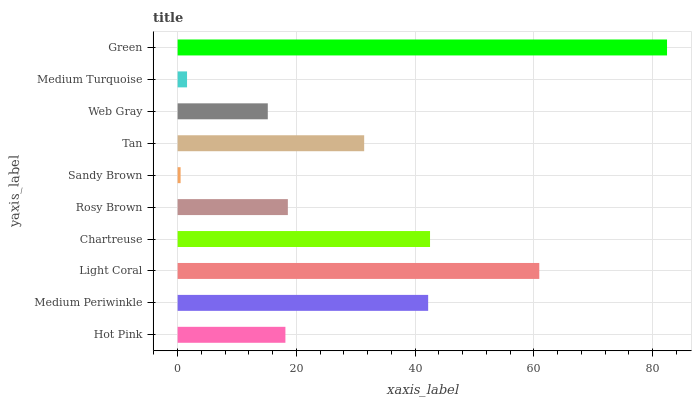Is Sandy Brown the minimum?
Answer yes or no. Yes. Is Green the maximum?
Answer yes or no. Yes. Is Medium Periwinkle the minimum?
Answer yes or no. No. Is Medium Periwinkle the maximum?
Answer yes or no. No. Is Medium Periwinkle greater than Hot Pink?
Answer yes or no. Yes. Is Hot Pink less than Medium Periwinkle?
Answer yes or no. Yes. Is Hot Pink greater than Medium Periwinkle?
Answer yes or no. No. Is Medium Periwinkle less than Hot Pink?
Answer yes or no. No. Is Tan the high median?
Answer yes or no. Yes. Is Rosy Brown the low median?
Answer yes or no. Yes. Is Hot Pink the high median?
Answer yes or no. No. Is Sandy Brown the low median?
Answer yes or no. No. 